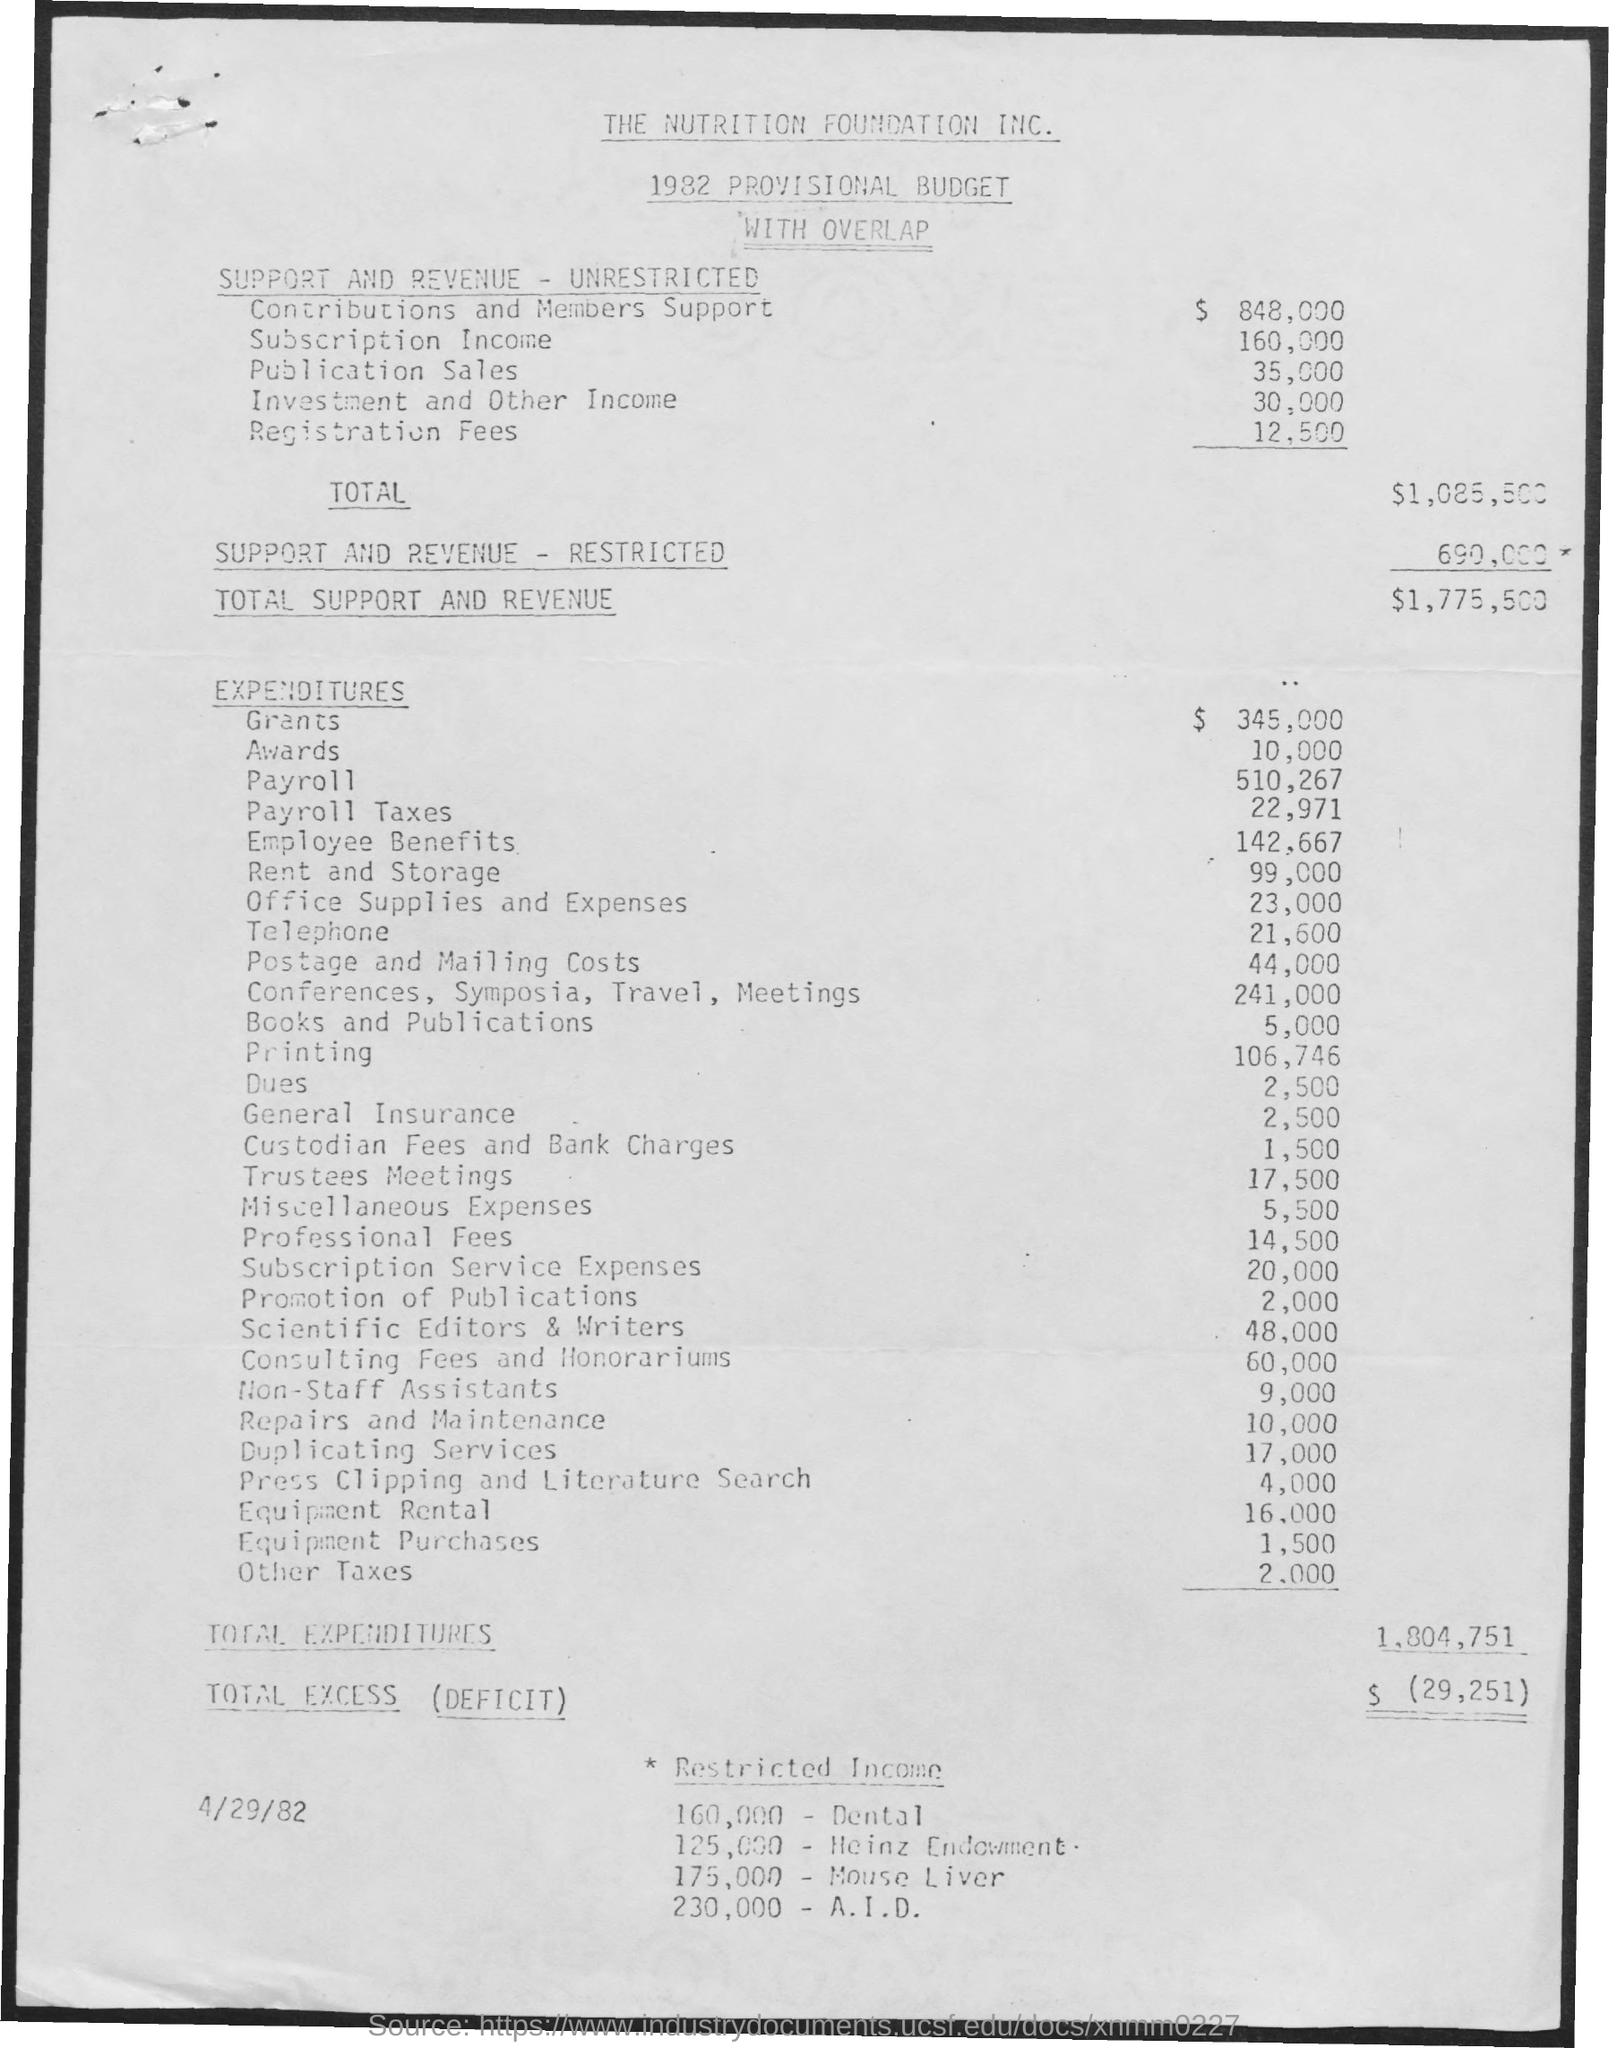Outline some significant characteristics in this image. The total support and revenue is 1,775,500. The Nutrition Foundation Inc. is the first title in the document. The cost of printing is 106,746. The total expenditure is 1,804,751. The second title in the document is "1982 Provisional Budget with Overlap." 